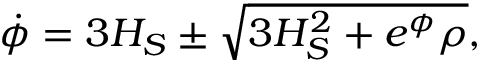Convert formula to latex. <formula><loc_0><loc_0><loc_500><loc_500>\dot { \phi } = 3 H _ { S } \pm \sqrt { 3 H _ { S } ^ { 2 } + e ^ { \phi } \rho } ,</formula> 